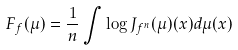Convert formula to latex. <formula><loc_0><loc_0><loc_500><loc_500>F _ { f } ( \mu ) = \frac { 1 } { n } \int \log J _ { f ^ { n } } ( \mu ) ( x ) d \mu ( x )</formula> 